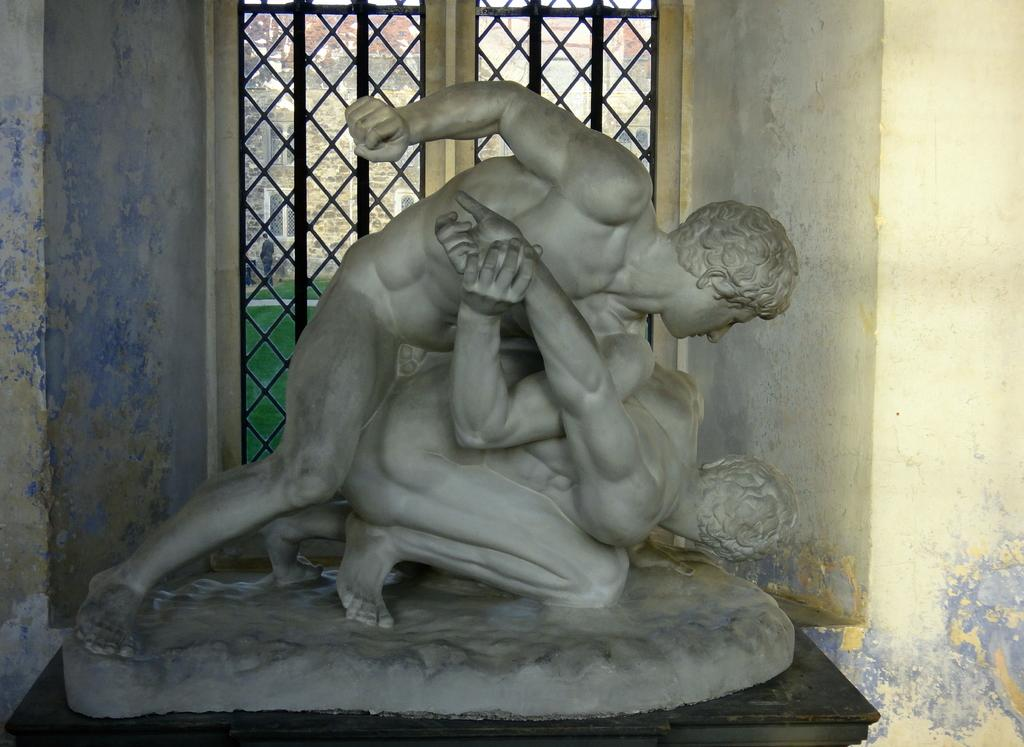What can be seen at the front of the image? There are statues in the front of the image. What is visible in the background of the image? There is a window in the background of the image. What can be seen through the window? Grass is visible on the ground behind the window. What structure is visible behind the window? There is a building behind the window. What type of stem can be seen growing from the grass in the image? There is no stem growing from the grass in the image; it is simply grass visible on the ground. How many fingers are visible on the statues in the image? The statues do not have fingers, as they are not human figures; they are inanimate objects. 